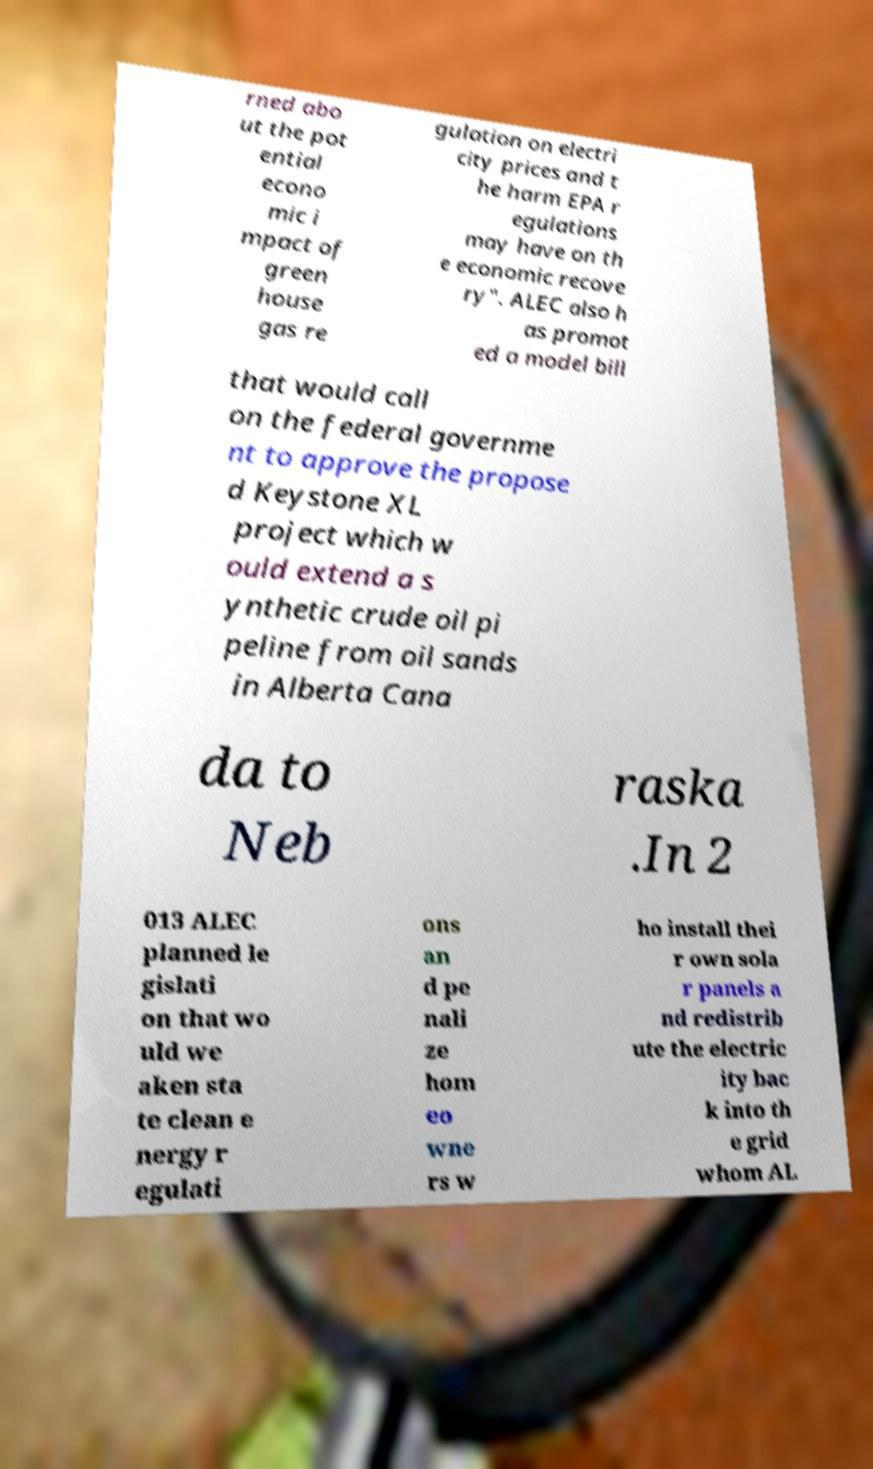Can you accurately transcribe the text from the provided image for me? rned abo ut the pot ential econo mic i mpact of green house gas re gulation on electri city prices and t he harm EPA r egulations may have on th e economic recove ry". ALEC also h as promot ed a model bill that would call on the federal governme nt to approve the propose d Keystone XL project which w ould extend a s ynthetic crude oil pi peline from oil sands in Alberta Cana da to Neb raska .In 2 013 ALEC planned le gislati on that wo uld we aken sta te clean e nergy r egulati ons an d pe nali ze hom eo wne rs w ho install thei r own sola r panels a nd redistrib ute the electric ity bac k into th e grid whom AL 